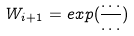Convert formula to latex. <formula><loc_0><loc_0><loc_500><loc_500>W _ { i + 1 } = e x p ( \frac { \dots } { \dots } )</formula> 